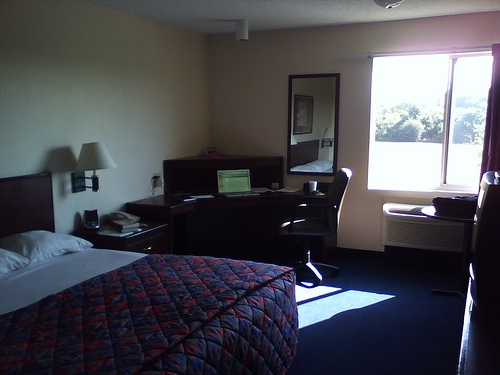Describe the objects in this image and their specific colors. I can see bed in black, gray, and navy tones, tv in black, white, navy, and gray tones, chair in black, gray, white, and navy tones, laptop in black, darkgreen, and teal tones, and book in black and gray tones in this image. 